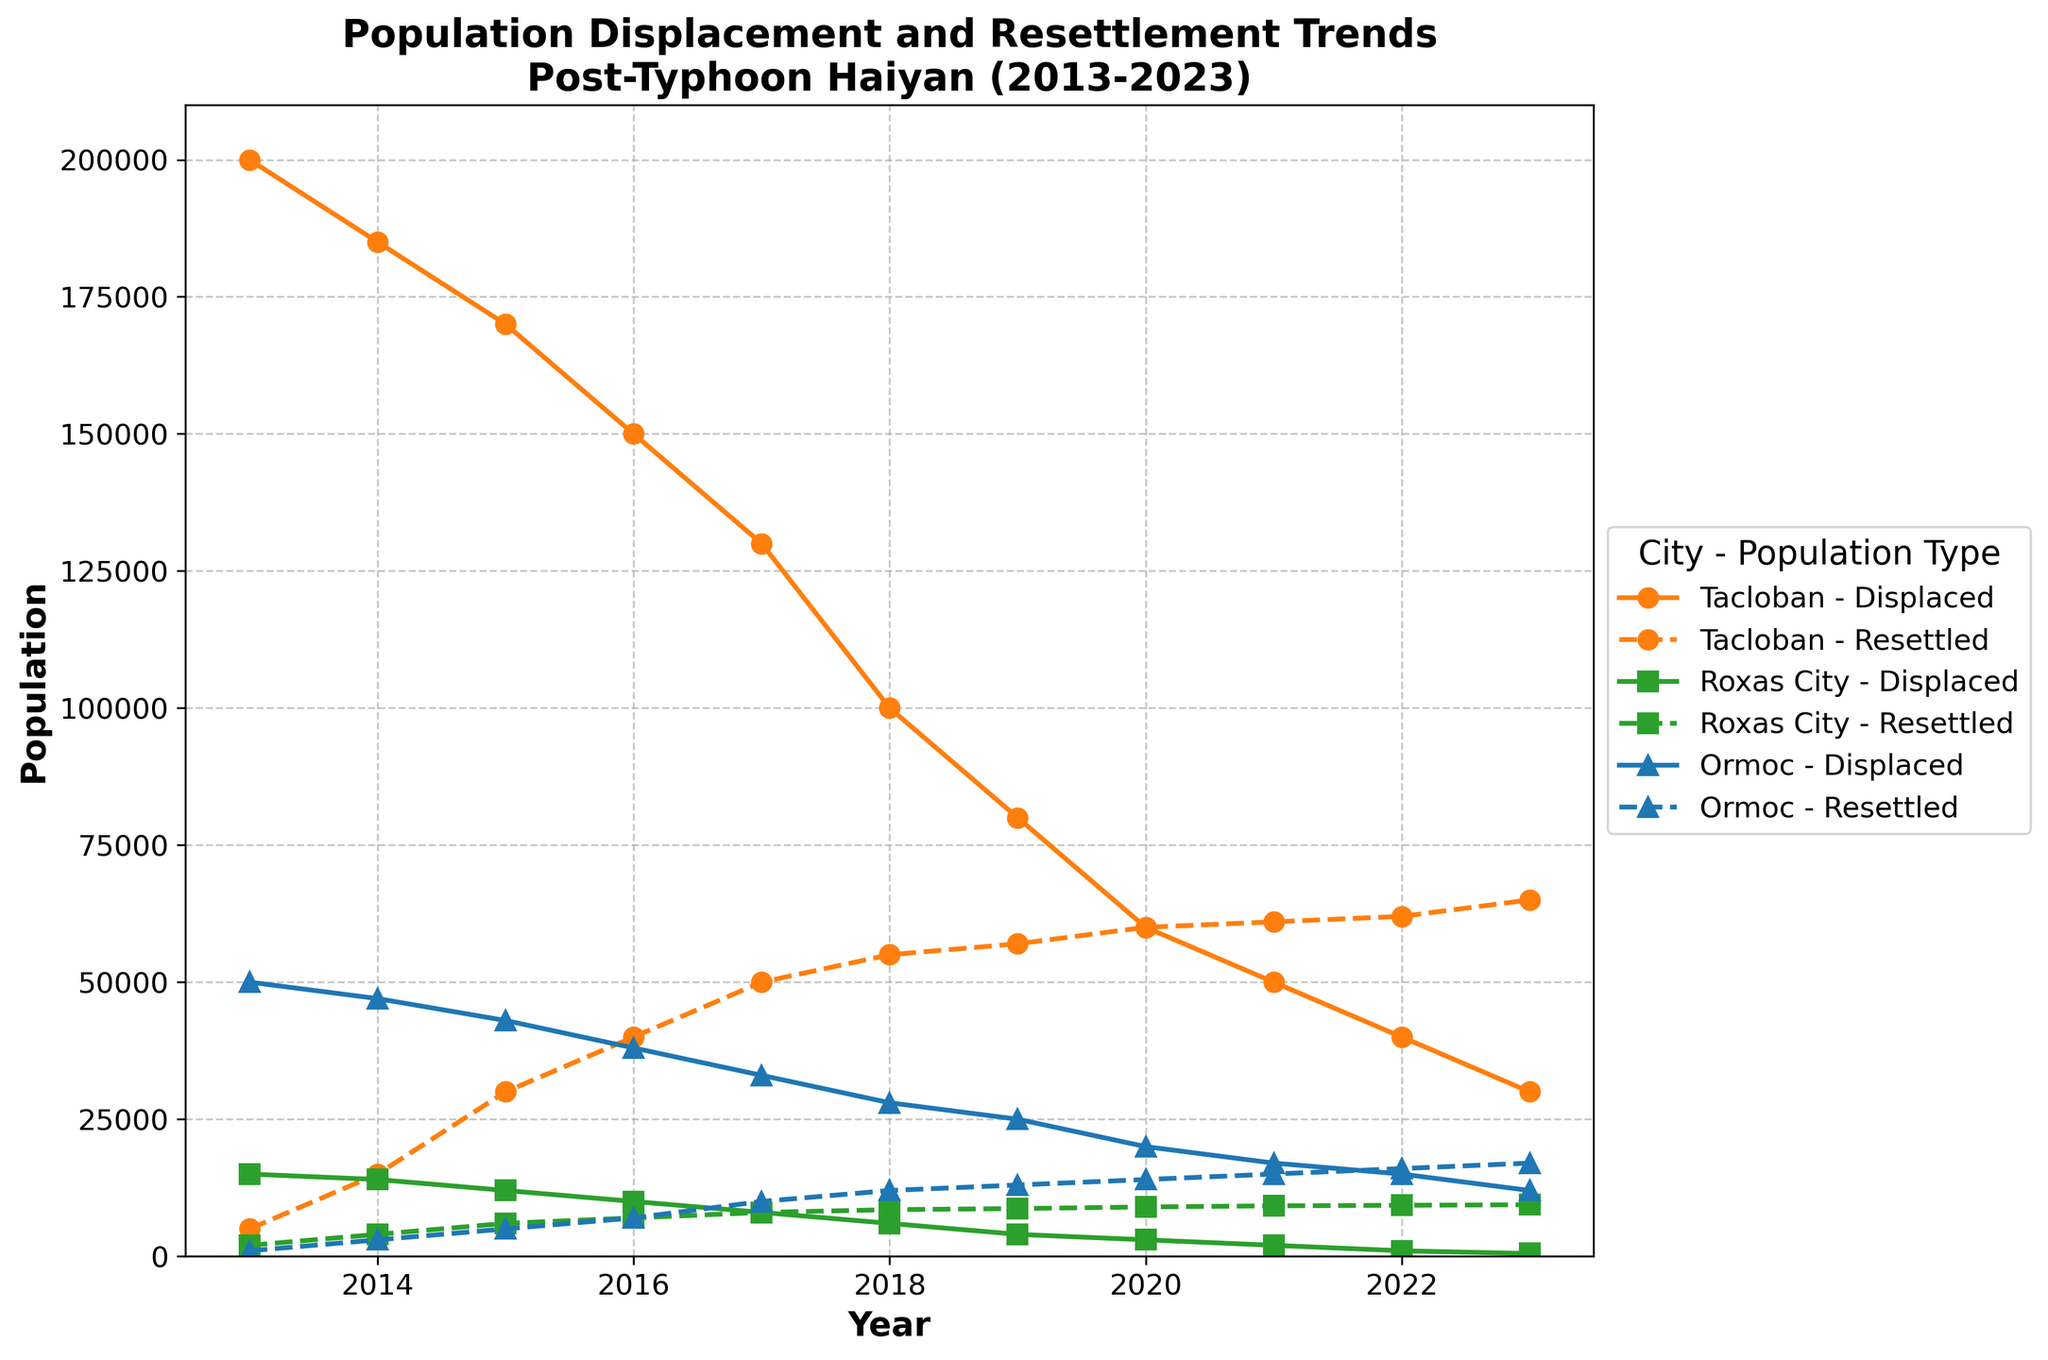What is the trend in the displaced population of Tacloban from 2013 to 2023? The displaced population in Tacloban decreases over the period from 200,000 in 2013 to 30,000 in 2023.
Answer: Decreasing How many people were resettled in Roxas City in 2020? The plot line for resettled population in Roxas City in 2020 indicates an approximate value of 9,000.
Answer: 9,000 Which city saw the highest number of displaced people in 2013? The plot for displaced population in 2013 shows that Tacloban has the highest number of displaced people at 200,000.
Answer: Tacloban By how much did the resettled population in Ormoc increase from 2016 to 2020? The resettled population in Ormoc in 2016 is 7,000 and in 2020 it is 14,000. The increase is 14,000 - 7,000 = 7,000.
Answer: 7,000 In which year did Tacloban see an equal number of displaced and resettled populations? The plot shows that in 2020, the displaced and resettled populations in Tacloban were both about 60,000.
Answer: 2020 For Roxas City, how does the trend in resettled population compare to the trend in displaced population from 2013 to 2023? The plot indicates that while the displaced population in Roxas City steadily decreases from 15,000 in 2013 to 500 in 2023, the resettled population steadily increases from 2,000 in 2013 to 9,400 in 2023.
Answer: Displaced decreases, Resettled increases Which city had the smallest displaced population in 2018? The plot shows that in 2018, Roxas City had the smallest displaced population, around 6,000.
Answer: Roxas City How did the number of unsuccessful resettlements in Tacloban change from 2013 to 2023? Unsuccessful resettlements in Tacloban decreased from 500 in 2013 to 400 in 2023, showing a general downward trend.
Answer: Decreasing What was the general trend of the resettled population in Ormoc from 2013 to 2023? The plot shows a steady increase in the resettled population in Ormoc from 1,000 in 2013 to 17,000 in 2023.
Answer: Increasing 